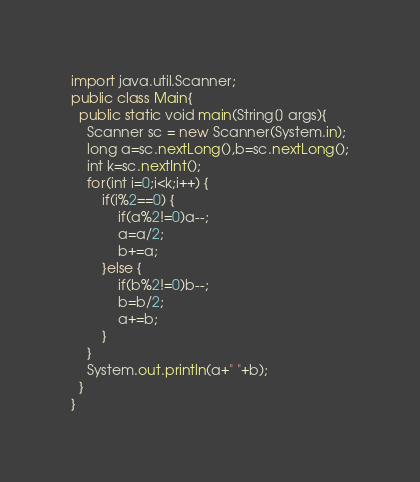Convert code to text. <code><loc_0><loc_0><loc_500><loc_500><_Java_>import java.util.Scanner;
public class Main{
  public static void main(String[] args){
    Scanner sc = new Scanner(System.in);
    long a=sc.nextLong(),b=sc.nextLong();
    int k=sc.nextInt();
    for(int i=0;i<k;i++) {
    	if(i%2==0) {
	    	if(a%2!=0)a--;
			a=a/2;
			b+=a;
    	}else {
			if(b%2!=0)b--;
			b=b/2;
			a+=b;
    	}
    }
    System.out.println(a+" "+b);
  }
}
</code> 